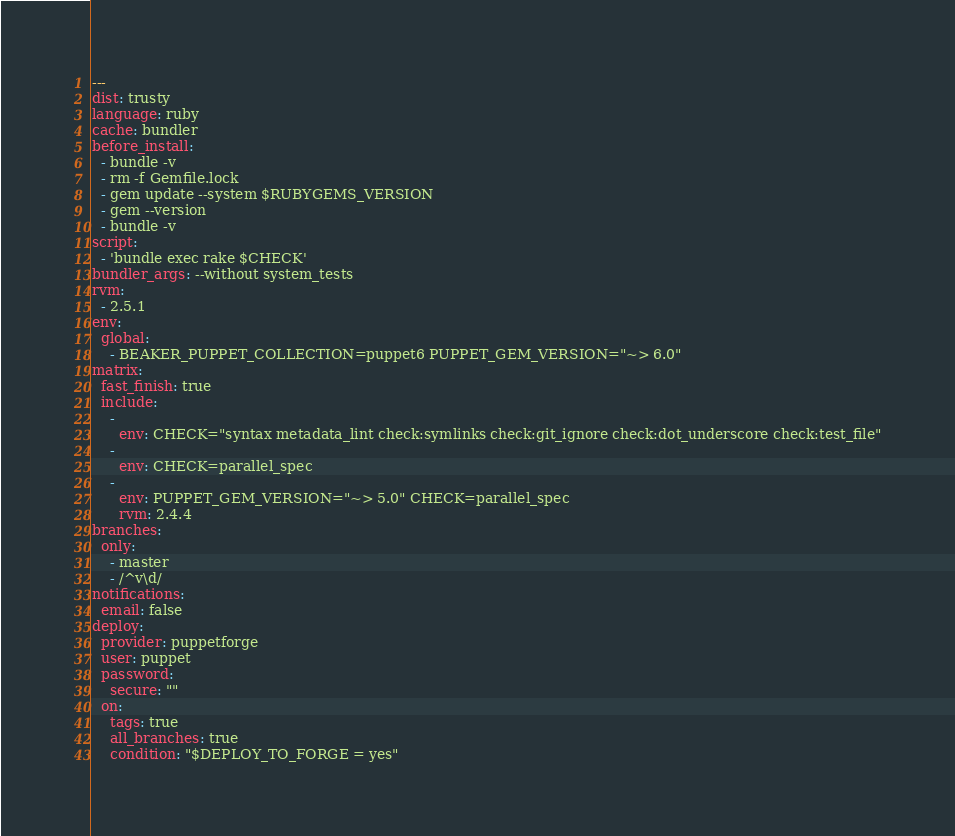<code> <loc_0><loc_0><loc_500><loc_500><_YAML_>---
dist: trusty
language: ruby
cache: bundler
before_install:
  - bundle -v
  - rm -f Gemfile.lock
  - gem update --system $RUBYGEMS_VERSION
  - gem --version
  - bundle -v
script:
  - 'bundle exec rake $CHECK'
bundler_args: --without system_tests
rvm:
  - 2.5.1
env:
  global:
    - BEAKER_PUPPET_COLLECTION=puppet6 PUPPET_GEM_VERSION="~> 6.0"
matrix:
  fast_finish: true
  include:
    -
      env: CHECK="syntax metadata_lint check:symlinks check:git_ignore check:dot_underscore check:test_file"
    -
      env: CHECK=parallel_spec
    -
      env: PUPPET_GEM_VERSION="~> 5.0" CHECK=parallel_spec
      rvm: 2.4.4
branches:
  only:
    - master
    - /^v\d/
notifications:
  email: false
deploy:
  provider: puppetforge
  user: puppet
  password:
    secure: ""
  on:
    tags: true
    all_branches: true
    condition: "$DEPLOY_TO_FORGE = yes"
</code> 